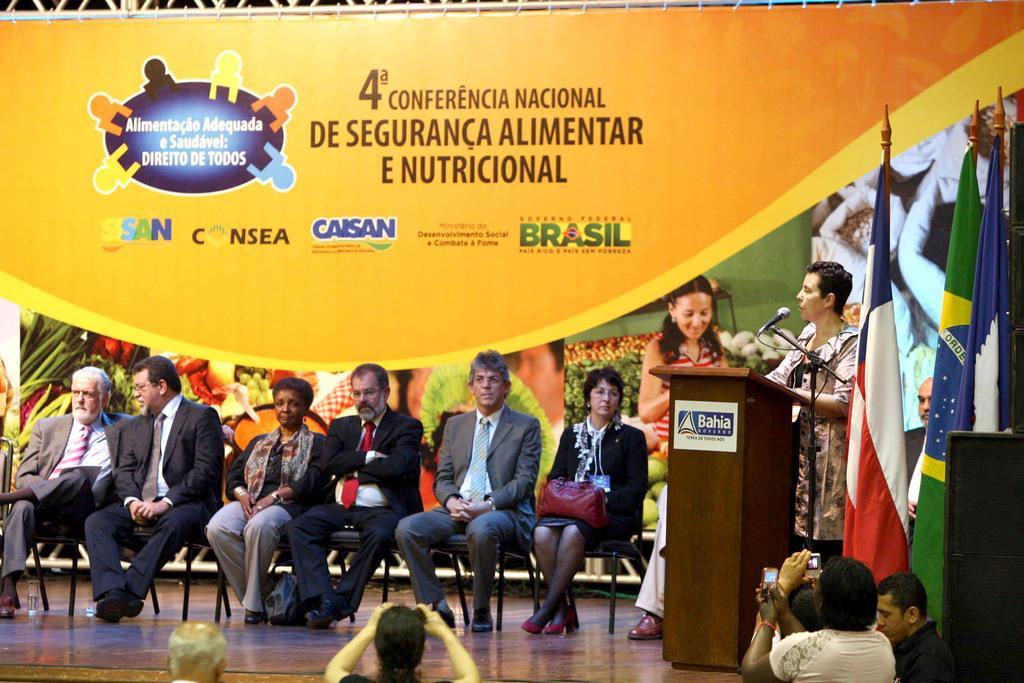Please provide a concise description of this image. This picture describes about group of people, few are seated and few are standing, in the right side of the given image we can see few flags and a speaker, in this we can find a person is speaking in front of the microphone, in the background we can find metal rods and a hoarding. 